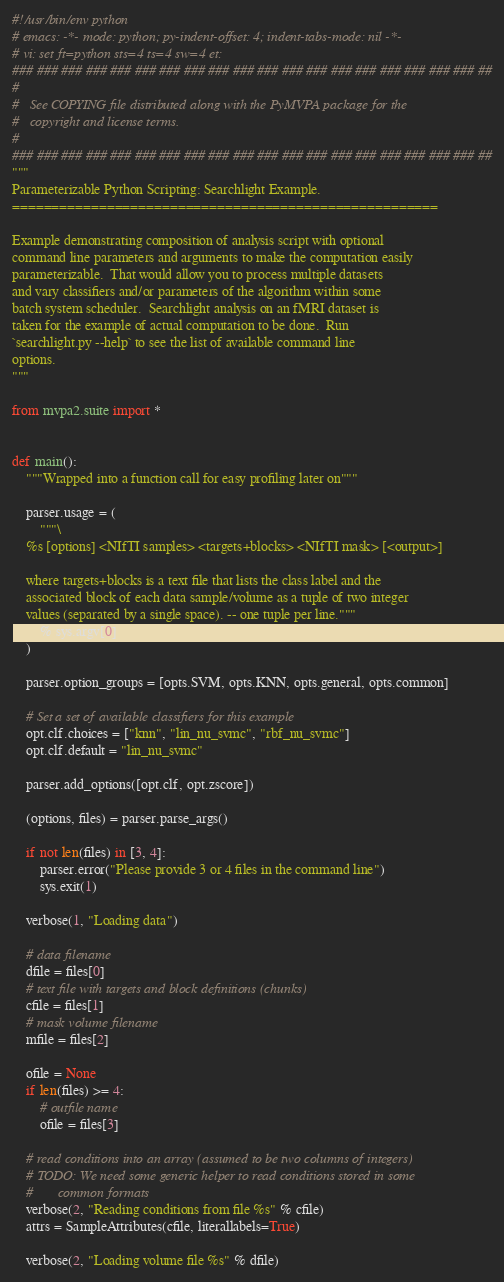Convert code to text. <code><loc_0><loc_0><loc_500><loc_500><_Python_>#!/usr/bin/env python
# emacs: -*- mode: python; py-indent-offset: 4; indent-tabs-mode: nil -*-
# vi: set ft=python sts=4 ts=4 sw=4 et:
### ### ### ### ### ### ### ### ### ### ### ### ### ### ### ### ### ### ### ##
#
#   See COPYING file distributed along with the PyMVPA package for the
#   copyright and license terms.
#
### ### ### ### ### ### ### ### ### ### ### ### ### ### ### ### ### ### ### ##
"""
Parameterizable Python Scripting: Searchlight Example.
======================================================

Example demonstrating composition of analysis script with optional
command line parameters and arguments to make the computation easily
parameterizable.  That would allow you to process multiple datasets
and vary classifiers and/or parameters of the algorithm within some
batch system scheduler.  Searchlight analysis on an fMRI dataset is
taken for the example of actual computation to be done.  Run
`searchlight.py --help` to see the list of available command line
options.
"""

from mvpa2.suite import *


def main():
    """Wrapped into a function call for easy profiling later on"""

    parser.usage = (
        """\
    %s [options] <NIfTI samples> <targets+blocks> <NIfTI mask> [<output>]

    where targets+blocks is a text file that lists the class label and the
    associated block of each data sample/volume as a tuple of two integer
    values (separated by a single space). -- one tuple per line."""
        % sys.argv[0]
    )

    parser.option_groups = [opts.SVM, opts.KNN, opts.general, opts.common]

    # Set a set of available classifiers for this example
    opt.clf.choices = ["knn", "lin_nu_svmc", "rbf_nu_svmc"]
    opt.clf.default = "lin_nu_svmc"

    parser.add_options([opt.clf, opt.zscore])

    (options, files) = parser.parse_args()

    if not len(files) in [3, 4]:
        parser.error("Please provide 3 or 4 files in the command line")
        sys.exit(1)

    verbose(1, "Loading data")

    # data filename
    dfile = files[0]
    # text file with targets and block definitions (chunks)
    cfile = files[1]
    # mask volume filename
    mfile = files[2]

    ofile = None
    if len(files) >= 4:
        # outfile name
        ofile = files[3]

    # read conditions into an array (assumed to be two columns of integers)
    # TODO: We need some generic helper to read conditions stored in some
    #       common formats
    verbose(2, "Reading conditions from file %s" % cfile)
    attrs = SampleAttributes(cfile, literallabels=True)

    verbose(2, "Loading volume file %s" % dfile)</code> 